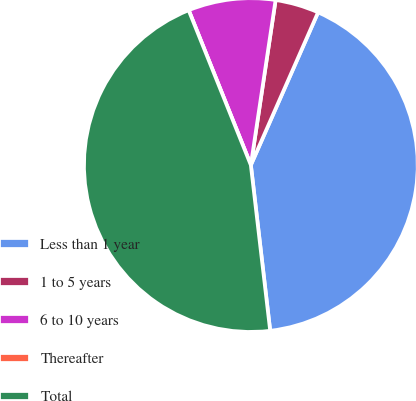<chart> <loc_0><loc_0><loc_500><loc_500><pie_chart><fcel>Less than 1 year<fcel>1 to 5 years<fcel>6 to 10 years<fcel>Thereafter<fcel>Total<nl><fcel>41.55%<fcel>4.23%<fcel>8.45%<fcel>0.0%<fcel>45.77%<nl></chart> 